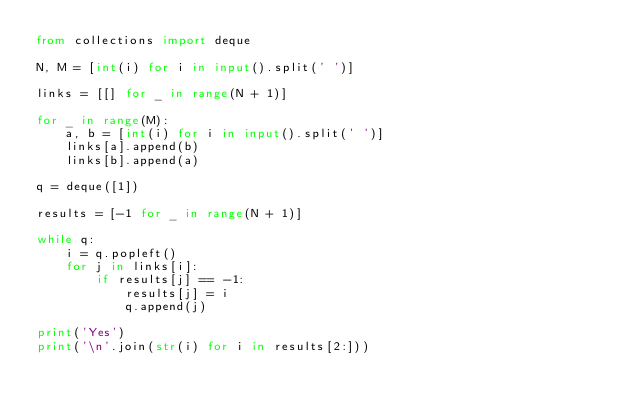Convert code to text. <code><loc_0><loc_0><loc_500><loc_500><_Python_>from collections import deque

N, M = [int(i) for i in input().split(' ')]
    
links = [[] for _ in range(N + 1)]

for _ in range(M):
    a, b = [int(i) for i in input().split(' ')]
    links[a].append(b)
    links[b].append(a)

q = deque([1])

results = [-1 for _ in range(N + 1)]

while q:
    i = q.popleft()
    for j in links[i]:
        if results[j] == -1:
            results[j] = i
            q.append(j)

print('Yes')
print('\n'.join(str(i) for i in results[2:]))</code> 